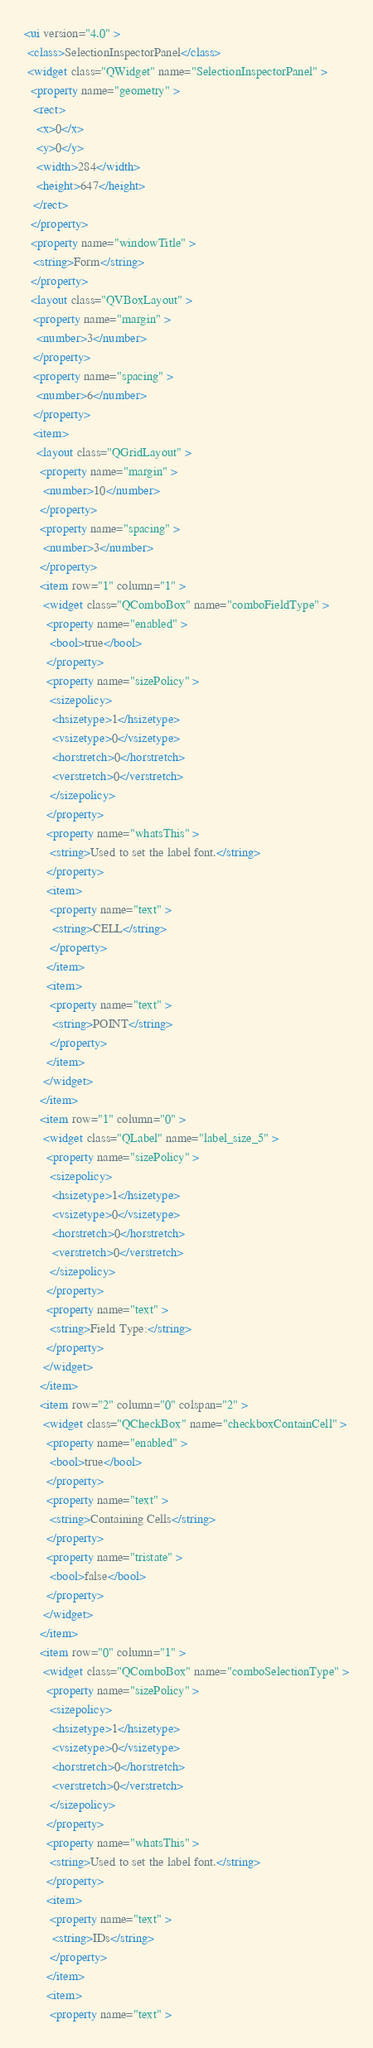<code> <loc_0><loc_0><loc_500><loc_500><_XML_><ui version="4.0" >
 <class>SelectionInspectorPanel</class>
 <widget class="QWidget" name="SelectionInspectorPanel" >
  <property name="geometry" >
   <rect>
    <x>0</x>
    <y>0</y>
    <width>284</width>
    <height>647</height>
   </rect>
  </property>
  <property name="windowTitle" >
   <string>Form</string>
  </property>
  <layout class="QVBoxLayout" >
   <property name="margin" >
    <number>3</number>
   </property>
   <property name="spacing" >
    <number>6</number>
   </property>
   <item>
    <layout class="QGridLayout" >
     <property name="margin" >
      <number>10</number>
     </property>
     <property name="spacing" >
      <number>3</number>
     </property>
     <item row="1" column="1" >
      <widget class="QComboBox" name="comboFieldType" >
       <property name="enabled" >
        <bool>true</bool>
       </property>
       <property name="sizePolicy" >
        <sizepolicy>
         <hsizetype>1</hsizetype>
         <vsizetype>0</vsizetype>
         <horstretch>0</horstretch>
         <verstretch>0</verstretch>
        </sizepolicy>
       </property>
       <property name="whatsThis" >
        <string>Used to set the label font.</string>
       </property>
       <item>
        <property name="text" >
         <string>CELL</string>
        </property>
       </item>
       <item>
        <property name="text" >
         <string>POINT</string>
        </property>
       </item>
      </widget>
     </item>
     <item row="1" column="0" >
      <widget class="QLabel" name="label_size_5" >
       <property name="sizePolicy" >
        <sizepolicy>
         <hsizetype>1</hsizetype>
         <vsizetype>0</vsizetype>
         <horstretch>0</horstretch>
         <verstretch>0</verstretch>
        </sizepolicy>
       </property>
       <property name="text" >
        <string>Field Type:</string>
       </property>
      </widget>
     </item>
     <item row="2" column="0" colspan="2" >
      <widget class="QCheckBox" name="checkboxContainCell" >
       <property name="enabled" >
        <bool>true</bool>
       </property>
       <property name="text" >
        <string>Containing Cells</string>
       </property>
       <property name="tristate" >
        <bool>false</bool>
       </property>
      </widget>
     </item>
     <item row="0" column="1" >
      <widget class="QComboBox" name="comboSelectionType" >
       <property name="sizePolicy" >
        <sizepolicy>
         <hsizetype>1</hsizetype>
         <vsizetype>0</vsizetype>
         <horstretch>0</horstretch>
         <verstretch>0</verstretch>
        </sizepolicy>
       </property>
       <property name="whatsThis" >
        <string>Used to set the label font.</string>
       </property>
       <item>
        <property name="text" >
         <string>IDs</string>
        </property>
       </item>
       <item>
        <property name="text" ></code> 